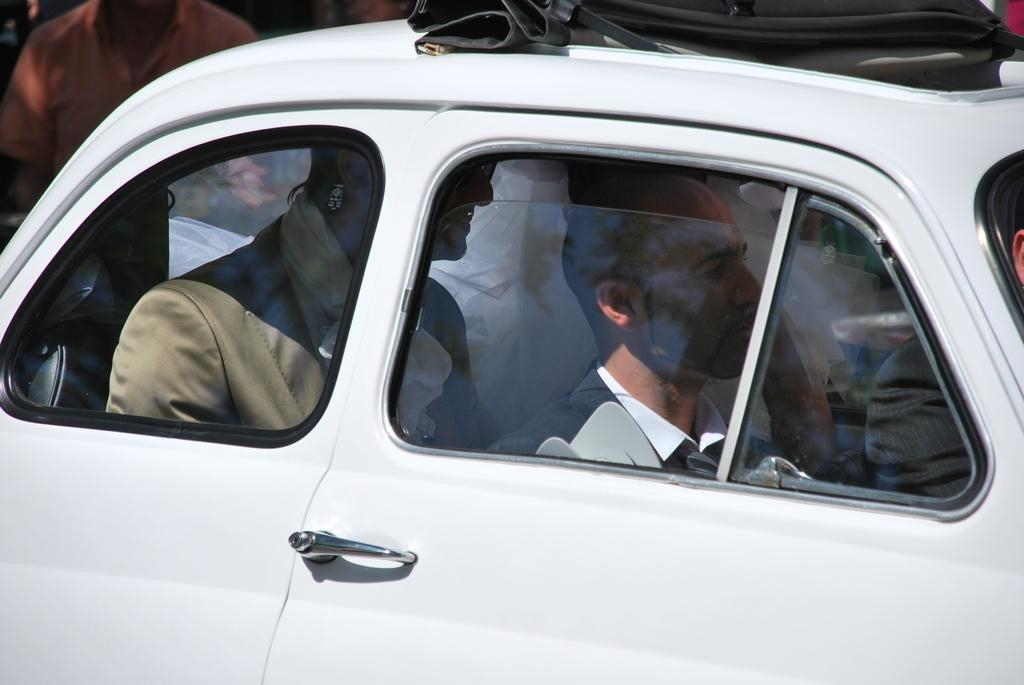What is the main subject of the picture? The main subject of the picture is a car. What is happening with the car in the image? There are people traveling in the car. How much salt is visible on the car in the image? There is no salt visible on the car in the image. Can you see a cat traveling in the car with the people? There is no cat present in the image; only people are traveling in the car. 